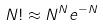<formula> <loc_0><loc_0><loc_500><loc_500>N ! \approx N ^ { N } e ^ { - N }</formula> 